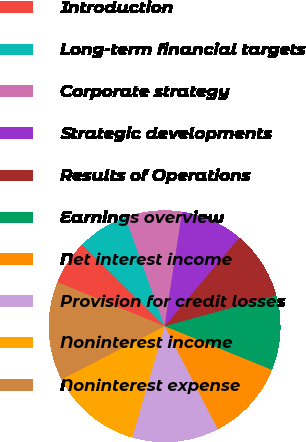Convert chart. <chart><loc_0><loc_0><loc_500><loc_500><pie_chart><fcel>Introduction<fcel>Long-term financial targets<fcel>Corporate strategy<fcel>Strategic developments<fcel>Results of Operations<fcel>Earnings overview<fcel>Net interest income<fcel>Provision for credit losses<fcel>Noninterest income<fcel>Noninterest expense<nl><fcel>6.23%<fcel>7.07%<fcel>7.91%<fcel>8.74%<fcel>9.58%<fcel>10.42%<fcel>11.26%<fcel>12.09%<fcel>12.93%<fcel>13.77%<nl></chart> 